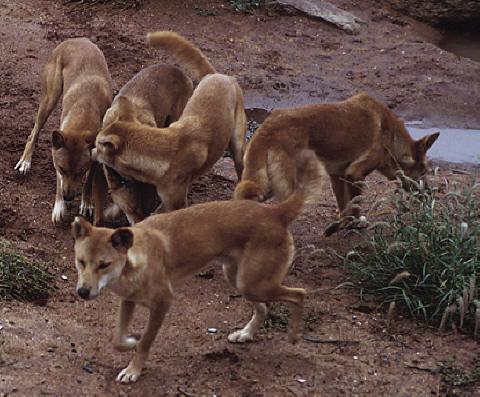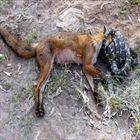The first image is the image on the left, the second image is the image on the right. Given the left and right images, does the statement "There are no more than two dingo's in the right image." hold true? Answer yes or no. Yes. 